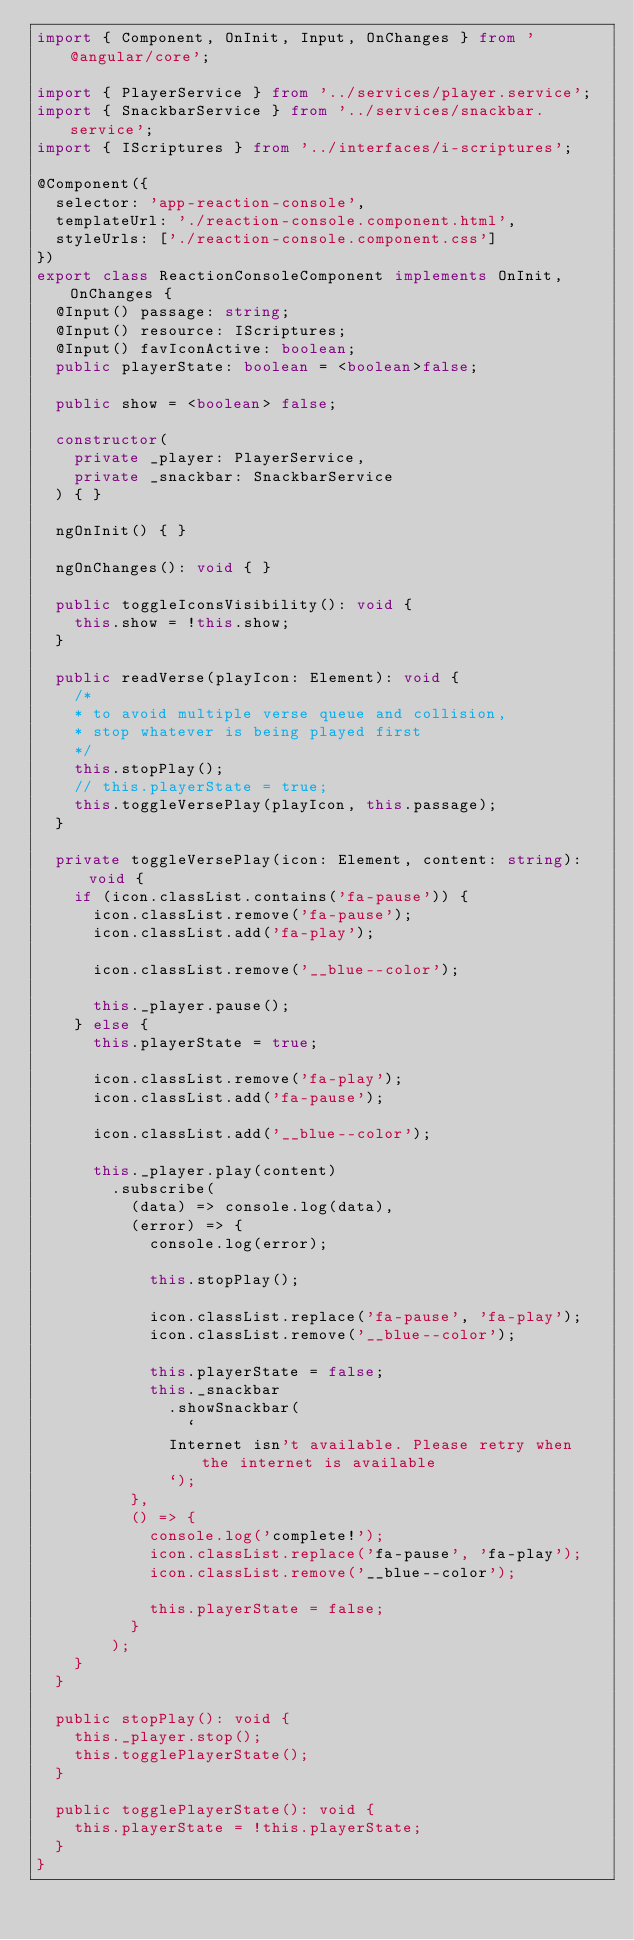<code> <loc_0><loc_0><loc_500><loc_500><_TypeScript_>import { Component, OnInit, Input, OnChanges } from '@angular/core';

import { PlayerService } from '../services/player.service';
import { SnackbarService } from '../services/snackbar.service';
import { IScriptures } from '../interfaces/i-scriptures';

@Component({
  selector: 'app-reaction-console',
  templateUrl: './reaction-console.component.html',
  styleUrls: ['./reaction-console.component.css']
})
export class ReactionConsoleComponent implements OnInit, OnChanges {
  @Input() passage: string;
  @Input() resource: IScriptures;
  @Input() favIconActive: boolean;
  public playerState: boolean = <boolean>false;

  public show = <boolean> false;

  constructor(
    private _player: PlayerService,
    private _snackbar: SnackbarService
  ) { }

  ngOnInit() { }

  ngOnChanges(): void { }

  public toggleIconsVisibility(): void {
    this.show = !this.show;
  }

  public readVerse(playIcon: Element): void {
    /*
    * to avoid multiple verse queue and collision,
    * stop whatever is being played first
    */
    this.stopPlay();
    // this.playerState = true;
    this.toggleVersePlay(playIcon, this.passage);
  }

  private toggleVersePlay(icon: Element, content: string): void {
    if (icon.classList.contains('fa-pause')) {
      icon.classList.remove('fa-pause');
      icon.classList.add('fa-play');

      icon.classList.remove('__blue--color');

      this._player.pause();
    } else {
      this.playerState = true;

      icon.classList.remove('fa-play');
      icon.classList.add('fa-pause');

      icon.classList.add('__blue--color');

      this._player.play(content)
        .subscribe(
          (data) => console.log(data),
          (error) => {
            console.log(error);

            this.stopPlay();

            icon.classList.replace('fa-pause', 'fa-play');
            icon.classList.remove('__blue--color');

            this.playerState = false;
            this._snackbar
              .showSnackbar(
                `
              Internet isn't available. Please retry when the internet is available
              `);
          },
          () => {
            console.log('complete!');
            icon.classList.replace('fa-pause', 'fa-play');
            icon.classList.remove('__blue--color');

            this.playerState = false;
          }
        );
    }
  }

  public stopPlay(): void {
    this._player.stop();
    this.togglePlayerState();
  }

  public togglePlayerState(): void {
    this.playerState = !this.playerState;
  }
}
</code> 